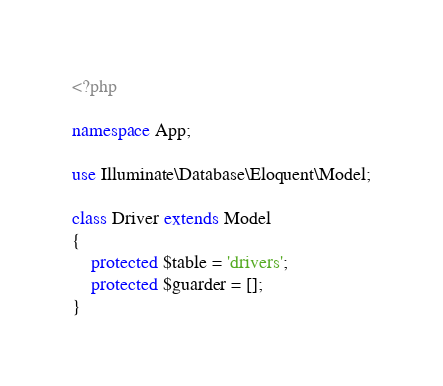<code> <loc_0><loc_0><loc_500><loc_500><_PHP_><?php

namespace App;

use Illuminate\Database\Eloquent\Model;

class Driver extends Model
{
    protected $table = 'drivers';
    protected $guarder = [];
}
</code> 